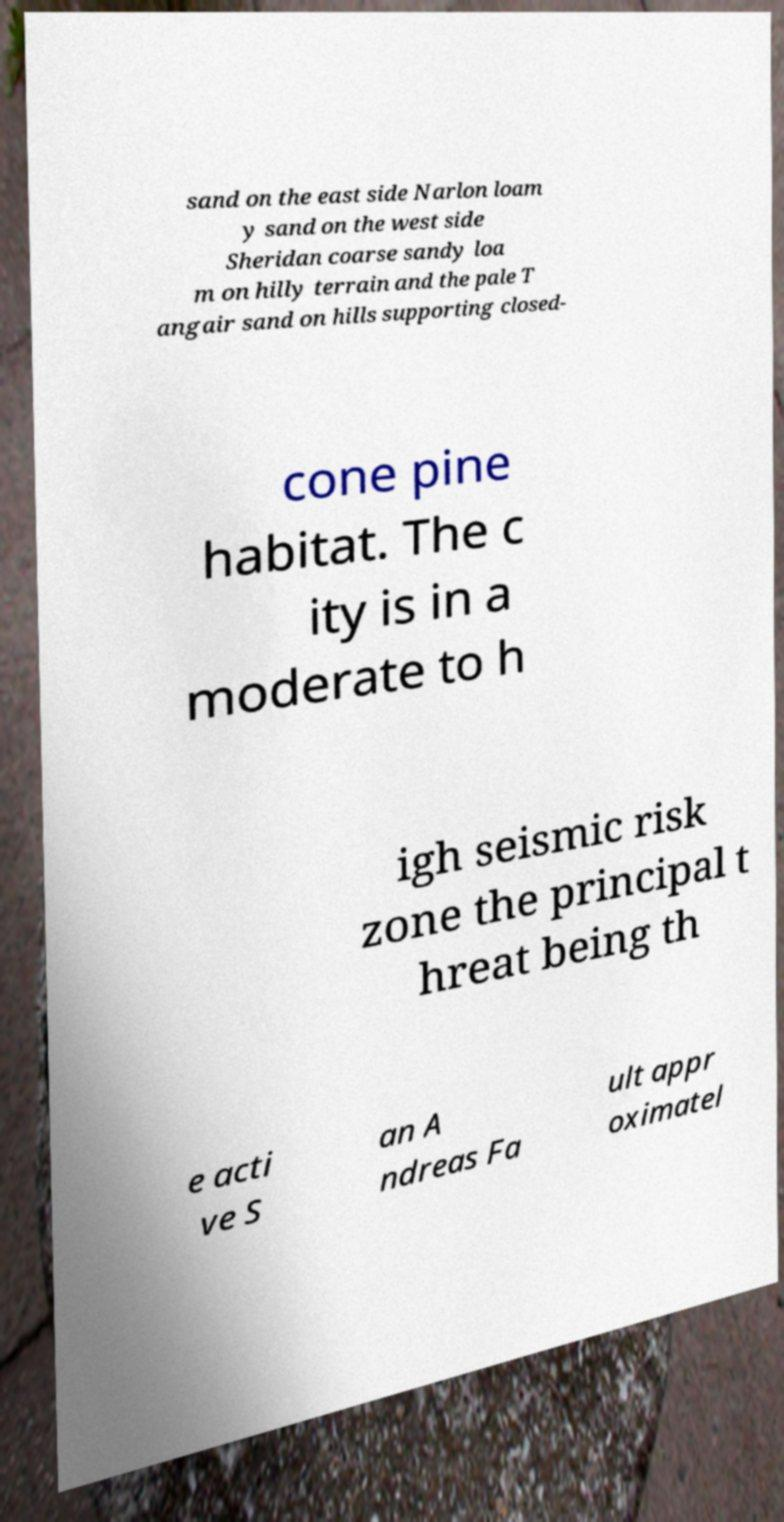I need the written content from this picture converted into text. Can you do that? sand on the east side Narlon loam y sand on the west side Sheridan coarse sandy loa m on hilly terrain and the pale T angair sand on hills supporting closed- cone pine habitat. The c ity is in a moderate to h igh seismic risk zone the principal t hreat being th e acti ve S an A ndreas Fa ult appr oximatel 